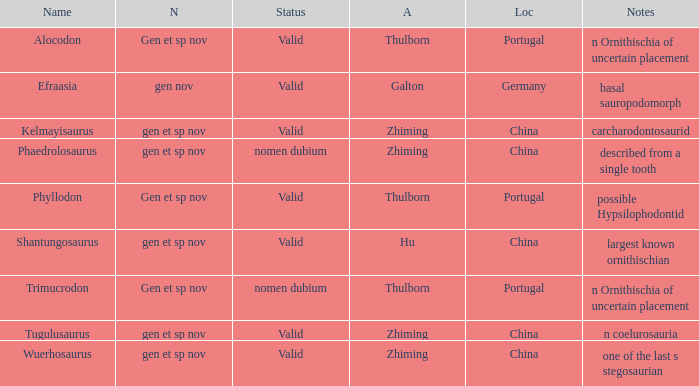What is the Status of the dinosaur, whose notes are, "n coelurosauria"? Valid. 